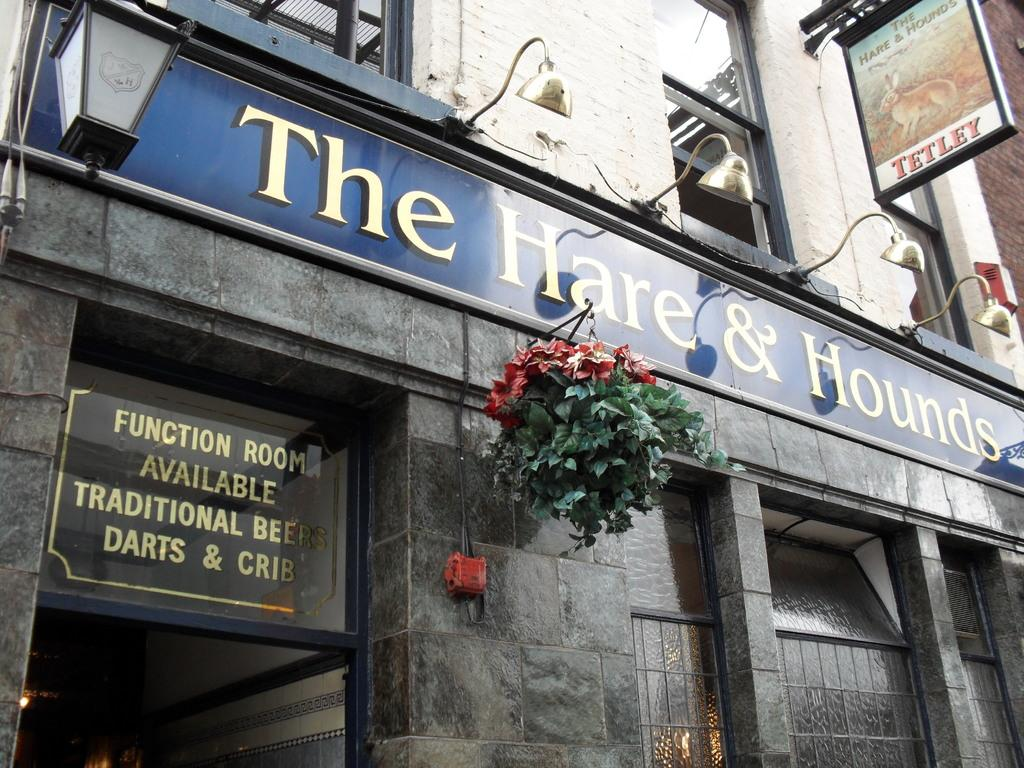Provide a one-sentence caption for the provided image. A sign notes the availability of rooms at the Hare and Hounds pub viewed from outside. 